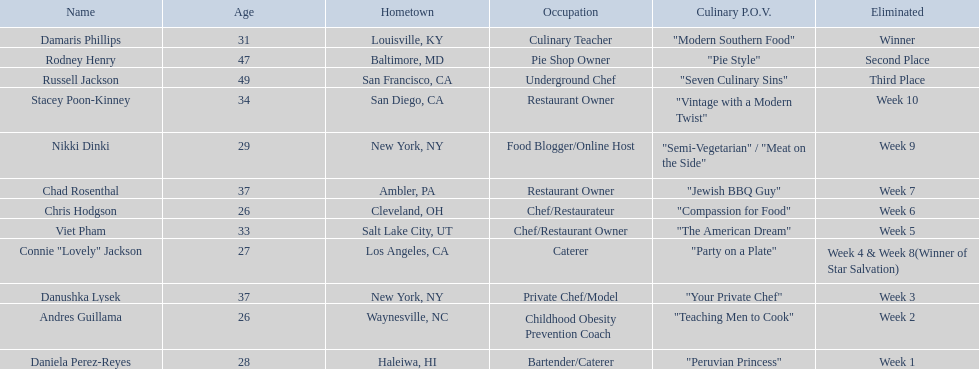Who are the participants? Damaris Phillips, 31, Rodney Henry, 47, Russell Jackson, 49, Stacey Poon-Kinney, 34, Nikki Dinki, 29, Chad Rosenthal, 37, Chris Hodgson, 26, Viet Pham, 33, Connie "Lovely" Jackson, 27, Danushka Lysek, 37, Andres Guillama, 26, Daniela Perez-Reyes, 28. How old is chris hodgson? 26. Which other competitor has that age? Andres Guillama. 